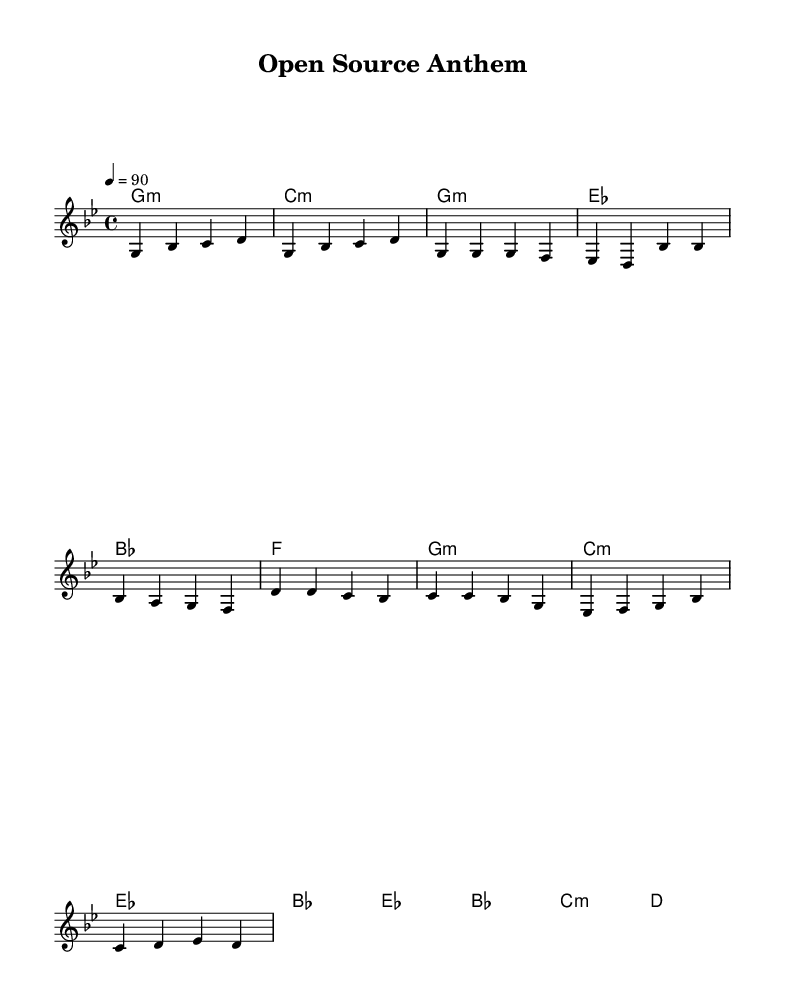What is the key signature of this music? The key signature is G minor, which has two flats (B flat and E flat). In the sheet music, this is indicated by the flat signs placed on the staff.
Answer: G minor What is the time signature of this music? The time signature is 4/4, which means there are four beats in each measure, and a quarter note gets one beat. This is typically indicated at the beginning of the piece, right after the key signature.
Answer: 4/4 What is the tempo marking in this score? The tempo marking is a quarter note equals 90 beats per minute, which indicates the speed of the music. This is specified in the score as "4 = 90" under the tempo instruction.
Answer: 90 How many measures are in the chorus section? The chorus section consists of 4 measures as seen in the corresponding section of the sheet music where the melody and harmonies are notated.
Answer: 4 What type of music is this composition? This composition is categorized as rap, as it celebrates open-source culture and features thematic elements relevant to technology and collaboration. The structure and flow are characteristic of hip-hop.
Answer: Rap Which chords are used in the bridge section? The bridge section uses the chords E flat, B flat, C minor, and D. These chords are present directly in the chord mode part of the score for that specific section.
Answer: E flat, B flat, C minor, D 